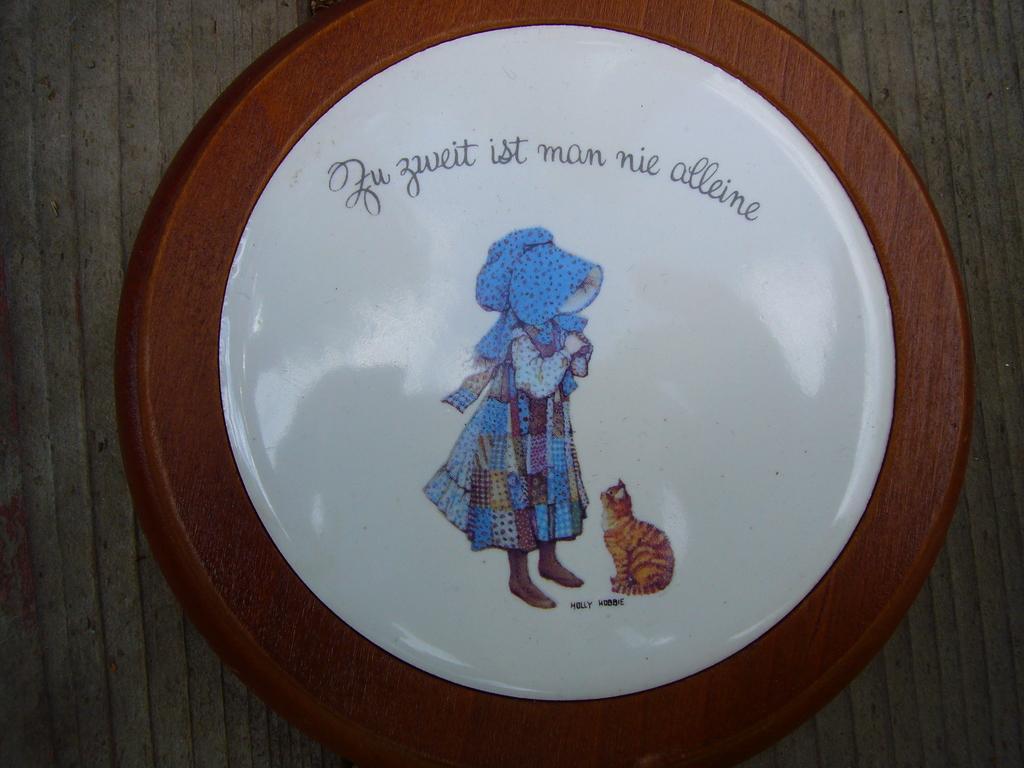In one or two sentences, can you explain what this image depicts? Here we can see a coin. On this coin we can see picture of a person, cat, and text written on it. 